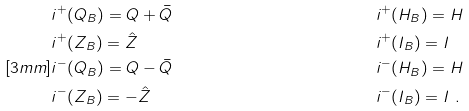<formula> <loc_0><loc_0><loc_500><loc_500>& i ^ { + } ( Q _ { B } ) = Q + \bar { Q } & & i ^ { + } ( H _ { B } ) = H \\ & i ^ { + } ( Z _ { B } ) = \hat { Z } & & i ^ { + } ( I _ { B } ) = I \\ [ 3 m m ] & i ^ { - } ( Q _ { B } ) = Q - \bar { Q } & & i ^ { - } ( H _ { B } ) = H \\ & i ^ { - } ( Z _ { B } ) = - \hat { Z } & & i ^ { - } ( I _ { B } ) = I \ .</formula> 